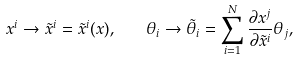<formula> <loc_0><loc_0><loc_500><loc_500>x ^ { i } \rightarrow { \tilde { x } } ^ { i } = { \tilde { x } } ^ { i } ( x ) , \quad \theta _ { i } \rightarrow { \tilde { \theta } } _ { i } = \sum _ { i = 1 } ^ { N } \frac { \partial x ^ { j } } { \partial { \tilde { x } } ^ { i } } \theta _ { j } ,</formula> 